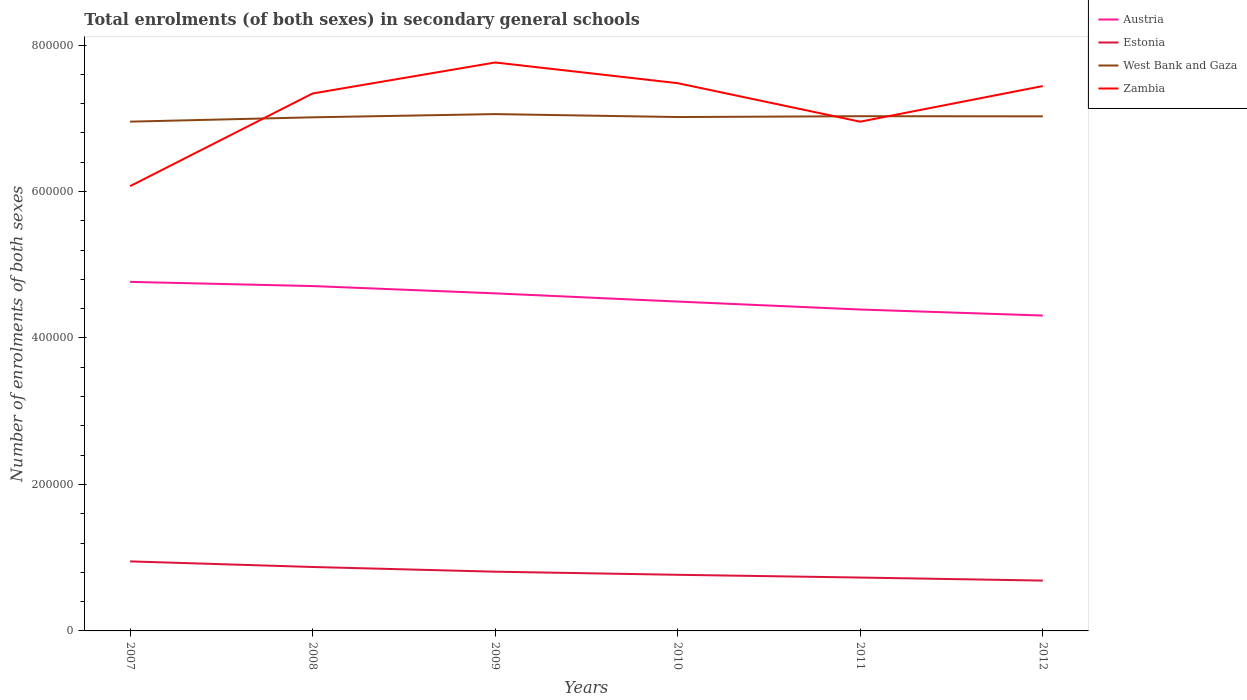How many different coloured lines are there?
Your answer should be very brief. 4. Across all years, what is the maximum number of enrolments in secondary schools in Estonia?
Your answer should be compact. 6.87e+04. What is the total number of enrolments in secondary schools in West Bank and Gaza in the graph?
Ensure brevity in your answer.  4036. What is the difference between the highest and the second highest number of enrolments in secondary schools in Austria?
Keep it short and to the point. 4.60e+04. How many lines are there?
Provide a succinct answer. 4. What is the difference between two consecutive major ticks on the Y-axis?
Ensure brevity in your answer.  2.00e+05. Are the values on the major ticks of Y-axis written in scientific E-notation?
Provide a short and direct response. No. Does the graph contain grids?
Ensure brevity in your answer.  No. How many legend labels are there?
Your answer should be very brief. 4. How are the legend labels stacked?
Provide a short and direct response. Vertical. What is the title of the graph?
Provide a succinct answer. Total enrolments (of both sexes) in secondary general schools. What is the label or title of the X-axis?
Your answer should be very brief. Years. What is the label or title of the Y-axis?
Offer a terse response. Number of enrolments of both sexes. What is the Number of enrolments of both sexes of Austria in 2007?
Your answer should be compact. 4.77e+05. What is the Number of enrolments of both sexes of Estonia in 2007?
Ensure brevity in your answer.  9.49e+04. What is the Number of enrolments of both sexes of West Bank and Gaza in 2007?
Offer a very short reply. 6.95e+05. What is the Number of enrolments of both sexes of Zambia in 2007?
Offer a very short reply. 6.07e+05. What is the Number of enrolments of both sexes in Austria in 2008?
Your response must be concise. 4.71e+05. What is the Number of enrolments of both sexes of Estonia in 2008?
Provide a short and direct response. 8.73e+04. What is the Number of enrolments of both sexes in West Bank and Gaza in 2008?
Offer a very short reply. 7.01e+05. What is the Number of enrolments of both sexes in Zambia in 2008?
Keep it short and to the point. 7.34e+05. What is the Number of enrolments of both sexes of Austria in 2009?
Give a very brief answer. 4.61e+05. What is the Number of enrolments of both sexes in Estonia in 2009?
Ensure brevity in your answer.  8.09e+04. What is the Number of enrolments of both sexes of West Bank and Gaza in 2009?
Your answer should be compact. 7.06e+05. What is the Number of enrolments of both sexes of Zambia in 2009?
Your response must be concise. 7.76e+05. What is the Number of enrolments of both sexes of Austria in 2010?
Your answer should be very brief. 4.50e+05. What is the Number of enrolments of both sexes in Estonia in 2010?
Your answer should be very brief. 7.66e+04. What is the Number of enrolments of both sexes of West Bank and Gaza in 2010?
Give a very brief answer. 7.02e+05. What is the Number of enrolments of both sexes in Zambia in 2010?
Your answer should be compact. 7.48e+05. What is the Number of enrolments of both sexes in Austria in 2011?
Offer a terse response. 4.39e+05. What is the Number of enrolments of both sexes in Estonia in 2011?
Your answer should be compact. 7.29e+04. What is the Number of enrolments of both sexes of West Bank and Gaza in 2011?
Your answer should be compact. 7.03e+05. What is the Number of enrolments of both sexes of Zambia in 2011?
Offer a very short reply. 6.95e+05. What is the Number of enrolments of both sexes of Austria in 2012?
Provide a short and direct response. 4.31e+05. What is the Number of enrolments of both sexes in Estonia in 2012?
Provide a succinct answer. 6.87e+04. What is the Number of enrolments of both sexes in West Bank and Gaza in 2012?
Provide a succinct answer. 7.03e+05. What is the Number of enrolments of both sexes in Zambia in 2012?
Your answer should be very brief. 7.44e+05. Across all years, what is the maximum Number of enrolments of both sexes of Austria?
Make the answer very short. 4.77e+05. Across all years, what is the maximum Number of enrolments of both sexes in Estonia?
Your response must be concise. 9.49e+04. Across all years, what is the maximum Number of enrolments of both sexes in West Bank and Gaza?
Your response must be concise. 7.06e+05. Across all years, what is the maximum Number of enrolments of both sexes of Zambia?
Make the answer very short. 7.76e+05. Across all years, what is the minimum Number of enrolments of both sexes of Austria?
Offer a terse response. 4.31e+05. Across all years, what is the minimum Number of enrolments of both sexes in Estonia?
Ensure brevity in your answer.  6.87e+04. Across all years, what is the minimum Number of enrolments of both sexes in West Bank and Gaza?
Your answer should be compact. 6.95e+05. Across all years, what is the minimum Number of enrolments of both sexes in Zambia?
Your answer should be very brief. 6.07e+05. What is the total Number of enrolments of both sexes of Austria in the graph?
Keep it short and to the point. 2.73e+06. What is the total Number of enrolments of both sexes in Estonia in the graph?
Provide a short and direct response. 4.81e+05. What is the total Number of enrolments of both sexes of West Bank and Gaza in the graph?
Offer a terse response. 4.21e+06. What is the total Number of enrolments of both sexes in Zambia in the graph?
Your response must be concise. 4.30e+06. What is the difference between the Number of enrolments of both sexes in Austria in 2007 and that in 2008?
Give a very brief answer. 5735. What is the difference between the Number of enrolments of both sexes of Estonia in 2007 and that in 2008?
Your response must be concise. 7637. What is the difference between the Number of enrolments of both sexes in West Bank and Gaza in 2007 and that in 2008?
Provide a short and direct response. -5912. What is the difference between the Number of enrolments of both sexes in Zambia in 2007 and that in 2008?
Provide a succinct answer. -1.27e+05. What is the difference between the Number of enrolments of both sexes in Austria in 2007 and that in 2009?
Ensure brevity in your answer.  1.57e+04. What is the difference between the Number of enrolments of both sexes of Estonia in 2007 and that in 2009?
Keep it short and to the point. 1.41e+04. What is the difference between the Number of enrolments of both sexes in West Bank and Gaza in 2007 and that in 2009?
Keep it short and to the point. -1.03e+04. What is the difference between the Number of enrolments of both sexes of Zambia in 2007 and that in 2009?
Provide a succinct answer. -1.69e+05. What is the difference between the Number of enrolments of both sexes of Austria in 2007 and that in 2010?
Your answer should be compact. 2.69e+04. What is the difference between the Number of enrolments of both sexes in Estonia in 2007 and that in 2010?
Your answer should be compact. 1.83e+04. What is the difference between the Number of enrolments of both sexes of West Bank and Gaza in 2007 and that in 2010?
Your response must be concise. -6284. What is the difference between the Number of enrolments of both sexes of Zambia in 2007 and that in 2010?
Make the answer very short. -1.41e+05. What is the difference between the Number of enrolments of both sexes of Austria in 2007 and that in 2011?
Your response must be concise. 3.77e+04. What is the difference between the Number of enrolments of both sexes of Estonia in 2007 and that in 2011?
Offer a terse response. 2.20e+04. What is the difference between the Number of enrolments of both sexes in West Bank and Gaza in 2007 and that in 2011?
Ensure brevity in your answer.  -7430. What is the difference between the Number of enrolments of both sexes of Zambia in 2007 and that in 2011?
Your answer should be very brief. -8.81e+04. What is the difference between the Number of enrolments of both sexes of Austria in 2007 and that in 2012?
Make the answer very short. 4.60e+04. What is the difference between the Number of enrolments of both sexes in Estonia in 2007 and that in 2012?
Ensure brevity in your answer.  2.62e+04. What is the difference between the Number of enrolments of both sexes of West Bank and Gaza in 2007 and that in 2012?
Offer a terse response. -7242. What is the difference between the Number of enrolments of both sexes in Zambia in 2007 and that in 2012?
Provide a succinct answer. -1.37e+05. What is the difference between the Number of enrolments of both sexes of Austria in 2008 and that in 2009?
Provide a short and direct response. 9955. What is the difference between the Number of enrolments of both sexes in Estonia in 2008 and that in 2009?
Your answer should be very brief. 6423. What is the difference between the Number of enrolments of both sexes of West Bank and Gaza in 2008 and that in 2009?
Give a very brief answer. -4408. What is the difference between the Number of enrolments of both sexes in Zambia in 2008 and that in 2009?
Your answer should be very brief. -4.23e+04. What is the difference between the Number of enrolments of both sexes in Austria in 2008 and that in 2010?
Provide a succinct answer. 2.12e+04. What is the difference between the Number of enrolments of both sexes of Estonia in 2008 and that in 2010?
Offer a very short reply. 1.07e+04. What is the difference between the Number of enrolments of both sexes of West Bank and Gaza in 2008 and that in 2010?
Provide a short and direct response. -372. What is the difference between the Number of enrolments of both sexes of Zambia in 2008 and that in 2010?
Ensure brevity in your answer.  -1.41e+04. What is the difference between the Number of enrolments of both sexes in Austria in 2008 and that in 2011?
Offer a terse response. 3.20e+04. What is the difference between the Number of enrolments of both sexes in Estonia in 2008 and that in 2011?
Offer a very short reply. 1.44e+04. What is the difference between the Number of enrolments of both sexes in West Bank and Gaza in 2008 and that in 2011?
Give a very brief answer. -1518. What is the difference between the Number of enrolments of both sexes in Zambia in 2008 and that in 2011?
Offer a terse response. 3.85e+04. What is the difference between the Number of enrolments of both sexes in Austria in 2008 and that in 2012?
Your answer should be compact. 4.02e+04. What is the difference between the Number of enrolments of both sexes in Estonia in 2008 and that in 2012?
Offer a very short reply. 1.86e+04. What is the difference between the Number of enrolments of both sexes of West Bank and Gaza in 2008 and that in 2012?
Give a very brief answer. -1330. What is the difference between the Number of enrolments of both sexes in Zambia in 2008 and that in 2012?
Ensure brevity in your answer.  -1.01e+04. What is the difference between the Number of enrolments of both sexes of Austria in 2009 and that in 2010?
Keep it short and to the point. 1.12e+04. What is the difference between the Number of enrolments of both sexes in Estonia in 2009 and that in 2010?
Provide a short and direct response. 4230. What is the difference between the Number of enrolments of both sexes in West Bank and Gaza in 2009 and that in 2010?
Keep it short and to the point. 4036. What is the difference between the Number of enrolments of both sexes of Zambia in 2009 and that in 2010?
Give a very brief answer. 2.83e+04. What is the difference between the Number of enrolments of both sexes of Austria in 2009 and that in 2011?
Your answer should be very brief. 2.21e+04. What is the difference between the Number of enrolments of both sexes of Estonia in 2009 and that in 2011?
Provide a short and direct response. 7990. What is the difference between the Number of enrolments of both sexes in West Bank and Gaza in 2009 and that in 2011?
Make the answer very short. 2890. What is the difference between the Number of enrolments of both sexes in Zambia in 2009 and that in 2011?
Make the answer very short. 8.08e+04. What is the difference between the Number of enrolments of both sexes of Austria in 2009 and that in 2012?
Your response must be concise. 3.03e+04. What is the difference between the Number of enrolments of both sexes of Estonia in 2009 and that in 2012?
Make the answer very short. 1.21e+04. What is the difference between the Number of enrolments of both sexes in West Bank and Gaza in 2009 and that in 2012?
Offer a terse response. 3078. What is the difference between the Number of enrolments of both sexes in Zambia in 2009 and that in 2012?
Ensure brevity in your answer.  3.22e+04. What is the difference between the Number of enrolments of both sexes in Austria in 2010 and that in 2011?
Provide a short and direct response. 1.08e+04. What is the difference between the Number of enrolments of both sexes in Estonia in 2010 and that in 2011?
Make the answer very short. 3760. What is the difference between the Number of enrolments of both sexes in West Bank and Gaza in 2010 and that in 2011?
Make the answer very short. -1146. What is the difference between the Number of enrolments of both sexes of Zambia in 2010 and that in 2011?
Give a very brief answer. 5.26e+04. What is the difference between the Number of enrolments of both sexes of Austria in 2010 and that in 2012?
Ensure brevity in your answer.  1.91e+04. What is the difference between the Number of enrolments of both sexes of Estonia in 2010 and that in 2012?
Keep it short and to the point. 7911. What is the difference between the Number of enrolments of both sexes in West Bank and Gaza in 2010 and that in 2012?
Your response must be concise. -958. What is the difference between the Number of enrolments of both sexes of Zambia in 2010 and that in 2012?
Your answer should be very brief. 3940. What is the difference between the Number of enrolments of both sexes in Austria in 2011 and that in 2012?
Your answer should be compact. 8222.16. What is the difference between the Number of enrolments of both sexes of Estonia in 2011 and that in 2012?
Offer a very short reply. 4151. What is the difference between the Number of enrolments of both sexes in West Bank and Gaza in 2011 and that in 2012?
Ensure brevity in your answer.  188. What is the difference between the Number of enrolments of both sexes in Zambia in 2011 and that in 2012?
Keep it short and to the point. -4.86e+04. What is the difference between the Number of enrolments of both sexes in Austria in 2007 and the Number of enrolments of both sexes in Estonia in 2008?
Provide a short and direct response. 3.89e+05. What is the difference between the Number of enrolments of both sexes of Austria in 2007 and the Number of enrolments of both sexes of West Bank and Gaza in 2008?
Provide a succinct answer. -2.25e+05. What is the difference between the Number of enrolments of both sexes in Austria in 2007 and the Number of enrolments of both sexes in Zambia in 2008?
Keep it short and to the point. -2.57e+05. What is the difference between the Number of enrolments of both sexes in Estonia in 2007 and the Number of enrolments of both sexes in West Bank and Gaza in 2008?
Make the answer very short. -6.06e+05. What is the difference between the Number of enrolments of both sexes of Estonia in 2007 and the Number of enrolments of both sexes of Zambia in 2008?
Provide a short and direct response. -6.39e+05. What is the difference between the Number of enrolments of both sexes in West Bank and Gaza in 2007 and the Number of enrolments of both sexes in Zambia in 2008?
Give a very brief answer. -3.85e+04. What is the difference between the Number of enrolments of both sexes of Austria in 2007 and the Number of enrolments of both sexes of Estonia in 2009?
Provide a succinct answer. 3.96e+05. What is the difference between the Number of enrolments of both sexes of Austria in 2007 and the Number of enrolments of both sexes of West Bank and Gaza in 2009?
Your answer should be compact. -2.29e+05. What is the difference between the Number of enrolments of both sexes of Austria in 2007 and the Number of enrolments of both sexes of Zambia in 2009?
Make the answer very short. -3.00e+05. What is the difference between the Number of enrolments of both sexes of Estonia in 2007 and the Number of enrolments of both sexes of West Bank and Gaza in 2009?
Offer a very short reply. -6.11e+05. What is the difference between the Number of enrolments of both sexes in Estonia in 2007 and the Number of enrolments of both sexes in Zambia in 2009?
Provide a short and direct response. -6.81e+05. What is the difference between the Number of enrolments of both sexes in West Bank and Gaza in 2007 and the Number of enrolments of both sexes in Zambia in 2009?
Give a very brief answer. -8.08e+04. What is the difference between the Number of enrolments of both sexes of Austria in 2007 and the Number of enrolments of both sexes of Estonia in 2010?
Keep it short and to the point. 4.00e+05. What is the difference between the Number of enrolments of both sexes in Austria in 2007 and the Number of enrolments of both sexes in West Bank and Gaza in 2010?
Provide a short and direct response. -2.25e+05. What is the difference between the Number of enrolments of both sexes of Austria in 2007 and the Number of enrolments of both sexes of Zambia in 2010?
Ensure brevity in your answer.  -2.71e+05. What is the difference between the Number of enrolments of both sexes in Estonia in 2007 and the Number of enrolments of both sexes in West Bank and Gaza in 2010?
Offer a terse response. -6.07e+05. What is the difference between the Number of enrolments of both sexes of Estonia in 2007 and the Number of enrolments of both sexes of Zambia in 2010?
Provide a short and direct response. -6.53e+05. What is the difference between the Number of enrolments of both sexes in West Bank and Gaza in 2007 and the Number of enrolments of both sexes in Zambia in 2010?
Provide a short and direct response. -5.25e+04. What is the difference between the Number of enrolments of both sexes of Austria in 2007 and the Number of enrolments of both sexes of Estonia in 2011?
Offer a very short reply. 4.04e+05. What is the difference between the Number of enrolments of both sexes in Austria in 2007 and the Number of enrolments of both sexes in West Bank and Gaza in 2011?
Keep it short and to the point. -2.26e+05. What is the difference between the Number of enrolments of both sexes of Austria in 2007 and the Number of enrolments of both sexes of Zambia in 2011?
Ensure brevity in your answer.  -2.19e+05. What is the difference between the Number of enrolments of both sexes of Estonia in 2007 and the Number of enrolments of both sexes of West Bank and Gaza in 2011?
Ensure brevity in your answer.  -6.08e+05. What is the difference between the Number of enrolments of both sexes of Estonia in 2007 and the Number of enrolments of both sexes of Zambia in 2011?
Ensure brevity in your answer.  -6.00e+05. What is the difference between the Number of enrolments of both sexes in Austria in 2007 and the Number of enrolments of both sexes in Estonia in 2012?
Make the answer very short. 4.08e+05. What is the difference between the Number of enrolments of both sexes in Austria in 2007 and the Number of enrolments of both sexes in West Bank and Gaza in 2012?
Provide a succinct answer. -2.26e+05. What is the difference between the Number of enrolments of both sexes in Austria in 2007 and the Number of enrolments of both sexes in Zambia in 2012?
Your answer should be very brief. -2.67e+05. What is the difference between the Number of enrolments of both sexes in Estonia in 2007 and the Number of enrolments of both sexes in West Bank and Gaza in 2012?
Your answer should be very brief. -6.08e+05. What is the difference between the Number of enrolments of both sexes in Estonia in 2007 and the Number of enrolments of both sexes in Zambia in 2012?
Keep it short and to the point. -6.49e+05. What is the difference between the Number of enrolments of both sexes of West Bank and Gaza in 2007 and the Number of enrolments of both sexes of Zambia in 2012?
Offer a terse response. -4.86e+04. What is the difference between the Number of enrolments of both sexes in Austria in 2008 and the Number of enrolments of both sexes in Estonia in 2009?
Give a very brief answer. 3.90e+05. What is the difference between the Number of enrolments of both sexes of Austria in 2008 and the Number of enrolments of both sexes of West Bank and Gaza in 2009?
Your answer should be very brief. -2.35e+05. What is the difference between the Number of enrolments of both sexes in Austria in 2008 and the Number of enrolments of both sexes in Zambia in 2009?
Make the answer very short. -3.05e+05. What is the difference between the Number of enrolments of both sexes in Estonia in 2008 and the Number of enrolments of both sexes in West Bank and Gaza in 2009?
Offer a terse response. -6.18e+05. What is the difference between the Number of enrolments of both sexes of Estonia in 2008 and the Number of enrolments of both sexes of Zambia in 2009?
Your response must be concise. -6.89e+05. What is the difference between the Number of enrolments of both sexes of West Bank and Gaza in 2008 and the Number of enrolments of both sexes of Zambia in 2009?
Your response must be concise. -7.49e+04. What is the difference between the Number of enrolments of both sexes in Austria in 2008 and the Number of enrolments of both sexes in Estonia in 2010?
Give a very brief answer. 3.94e+05. What is the difference between the Number of enrolments of both sexes of Austria in 2008 and the Number of enrolments of both sexes of West Bank and Gaza in 2010?
Keep it short and to the point. -2.31e+05. What is the difference between the Number of enrolments of both sexes of Austria in 2008 and the Number of enrolments of both sexes of Zambia in 2010?
Your answer should be compact. -2.77e+05. What is the difference between the Number of enrolments of both sexes of Estonia in 2008 and the Number of enrolments of both sexes of West Bank and Gaza in 2010?
Your answer should be compact. -6.14e+05. What is the difference between the Number of enrolments of both sexes of Estonia in 2008 and the Number of enrolments of both sexes of Zambia in 2010?
Provide a succinct answer. -6.61e+05. What is the difference between the Number of enrolments of both sexes in West Bank and Gaza in 2008 and the Number of enrolments of both sexes in Zambia in 2010?
Provide a short and direct response. -4.66e+04. What is the difference between the Number of enrolments of both sexes in Austria in 2008 and the Number of enrolments of both sexes in Estonia in 2011?
Offer a very short reply. 3.98e+05. What is the difference between the Number of enrolments of both sexes of Austria in 2008 and the Number of enrolments of both sexes of West Bank and Gaza in 2011?
Give a very brief answer. -2.32e+05. What is the difference between the Number of enrolments of both sexes of Austria in 2008 and the Number of enrolments of both sexes of Zambia in 2011?
Provide a short and direct response. -2.24e+05. What is the difference between the Number of enrolments of both sexes of Estonia in 2008 and the Number of enrolments of both sexes of West Bank and Gaza in 2011?
Offer a very short reply. -6.16e+05. What is the difference between the Number of enrolments of both sexes in Estonia in 2008 and the Number of enrolments of both sexes in Zambia in 2011?
Your response must be concise. -6.08e+05. What is the difference between the Number of enrolments of both sexes in West Bank and Gaza in 2008 and the Number of enrolments of both sexes in Zambia in 2011?
Offer a terse response. 5955. What is the difference between the Number of enrolments of both sexes of Austria in 2008 and the Number of enrolments of both sexes of Estonia in 2012?
Your answer should be very brief. 4.02e+05. What is the difference between the Number of enrolments of both sexes of Austria in 2008 and the Number of enrolments of both sexes of West Bank and Gaza in 2012?
Ensure brevity in your answer.  -2.32e+05. What is the difference between the Number of enrolments of both sexes of Austria in 2008 and the Number of enrolments of both sexes of Zambia in 2012?
Provide a short and direct response. -2.73e+05. What is the difference between the Number of enrolments of both sexes in Estonia in 2008 and the Number of enrolments of both sexes in West Bank and Gaza in 2012?
Provide a succinct answer. -6.15e+05. What is the difference between the Number of enrolments of both sexes in Estonia in 2008 and the Number of enrolments of both sexes in Zambia in 2012?
Your answer should be very brief. -6.57e+05. What is the difference between the Number of enrolments of both sexes of West Bank and Gaza in 2008 and the Number of enrolments of both sexes of Zambia in 2012?
Your answer should be very brief. -4.27e+04. What is the difference between the Number of enrolments of both sexes of Austria in 2009 and the Number of enrolments of both sexes of Estonia in 2010?
Your answer should be very brief. 3.84e+05. What is the difference between the Number of enrolments of both sexes in Austria in 2009 and the Number of enrolments of both sexes in West Bank and Gaza in 2010?
Ensure brevity in your answer.  -2.41e+05. What is the difference between the Number of enrolments of both sexes of Austria in 2009 and the Number of enrolments of both sexes of Zambia in 2010?
Ensure brevity in your answer.  -2.87e+05. What is the difference between the Number of enrolments of both sexes in Estonia in 2009 and the Number of enrolments of both sexes in West Bank and Gaza in 2010?
Your answer should be very brief. -6.21e+05. What is the difference between the Number of enrolments of both sexes in Estonia in 2009 and the Number of enrolments of both sexes in Zambia in 2010?
Your answer should be very brief. -6.67e+05. What is the difference between the Number of enrolments of both sexes in West Bank and Gaza in 2009 and the Number of enrolments of both sexes in Zambia in 2010?
Your response must be concise. -4.22e+04. What is the difference between the Number of enrolments of both sexes in Austria in 2009 and the Number of enrolments of both sexes in Estonia in 2011?
Ensure brevity in your answer.  3.88e+05. What is the difference between the Number of enrolments of both sexes in Austria in 2009 and the Number of enrolments of both sexes in West Bank and Gaza in 2011?
Your answer should be compact. -2.42e+05. What is the difference between the Number of enrolments of both sexes in Austria in 2009 and the Number of enrolments of both sexes in Zambia in 2011?
Your response must be concise. -2.34e+05. What is the difference between the Number of enrolments of both sexes of Estonia in 2009 and the Number of enrolments of both sexes of West Bank and Gaza in 2011?
Offer a very short reply. -6.22e+05. What is the difference between the Number of enrolments of both sexes of Estonia in 2009 and the Number of enrolments of both sexes of Zambia in 2011?
Provide a succinct answer. -6.14e+05. What is the difference between the Number of enrolments of both sexes of West Bank and Gaza in 2009 and the Number of enrolments of both sexes of Zambia in 2011?
Your answer should be compact. 1.04e+04. What is the difference between the Number of enrolments of both sexes of Austria in 2009 and the Number of enrolments of both sexes of Estonia in 2012?
Provide a short and direct response. 3.92e+05. What is the difference between the Number of enrolments of both sexes in Austria in 2009 and the Number of enrolments of both sexes in West Bank and Gaza in 2012?
Give a very brief answer. -2.42e+05. What is the difference between the Number of enrolments of both sexes in Austria in 2009 and the Number of enrolments of both sexes in Zambia in 2012?
Give a very brief answer. -2.83e+05. What is the difference between the Number of enrolments of both sexes in Estonia in 2009 and the Number of enrolments of both sexes in West Bank and Gaza in 2012?
Ensure brevity in your answer.  -6.22e+05. What is the difference between the Number of enrolments of both sexes of Estonia in 2009 and the Number of enrolments of both sexes of Zambia in 2012?
Provide a succinct answer. -6.63e+05. What is the difference between the Number of enrolments of both sexes of West Bank and Gaza in 2009 and the Number of enrolments of both sexes of Zambia in 2012?
Make the answer very short. -3.83e+04. What is the difference between the Number of enrolments of both sexes in Austria in 2010 and the Number of enrolments of both sexes in Estonia in 2011?
Offer a terse response. 3.77e+05. What is the difference between the Number of enrolments of both sexes of Austria in 2010 and the Number of enrolments of both sexes of West Bank and Gaza in 2011?
Your answer should be compact. -2.53e+05. What is the difference between the Number of enrolments of both sexes of Austria in 2010 and the Number of enrolments of both sexes of Zambia in 2011?
Make the answer very short. -2.46e+05. What is the difference between the Number of enrolments of both sexes of Estonia in 2010 and the Number of enrolments of both sexes of West Bank and Gaza in 2011?
Provide a succinct answer. -6.26e+05. What is the difference between the Number of enrolments of both sexes in Estonia in 2010 and the Number of enrolments of both sexes in Zambia in 2011?
Your answer should be compact. -6.19e+05. What is the difference between the Number of enrolments of both sexes of West Bank and Gaza in 2010 and the Number of enrolments of both sexes of Zambia in 2011?
Provide a short and direct response. 6327. What is the difference between the Number of enrolments of both sexes in Austria in 2010 and the Number of enrolments of both sexes in Estonia in 2012?
Make the answer very short. 3.81e+05. What is the difference between the Number of enrolments of both sexes in Austria in 2010 and the Number of enrolments of both sexes in West Bank and Gaza in 2012?
Provide a short and direct response. -2.53e+05. What is the difference between the Number of enrolments of both sexes of Austria in 2010 and the Number of enrolments of both sexes of Zambia in 2012?
Make the answer very short. -2.94e+05. What is the difference between the Number of enrolments of both sexes of Estonia in 2010 and the Number of enrolments of both sexes of West Bank and Gaza in 2012?
Provide a succinct answer. -6.26e+05. What is the difference between the Number of enrolments of both sexes in Estonia in 2010 and the Number of enrolments of both sexes in Zambia in 2012?
Keep it short and to the point. -6.67e+05. What is the difference between the Number of enrolments of both sexes in West Bank and Gaza in 2010 and the Number of enrolments of both sexes in Zambia in 2012?
Your response must be concise. -4.23e+04. What is the difference between the Number of enrolments of both sexes in Austria in 2011 and the Number of enrolments of both sexes in Estonia in 2012?
Your answer should be very brief. 3.70e+05. What is the difference between the Number of enrolments of both sexes of Austria in 2011 and the Number of enrolments of both sexes of West Bank and Gaza in 2012?
Make the answer very short. -2.64e+05. What is the difference between the Number of enrolments of both sexes of Austria in 2011 and the Number of enrolments of both sexes of Zambia in 2012?
Give a very brief answer. -3.05e+05. What is the difference between the Number of enrolments of both sexes in Estonia in 2011 and the Number of enrolments of both sexes in West Bank and Gaza in 2012?
Offer a very short reply. -6.30e+05. What is the difference between the Number of enrolments of both sexes of Estonia in 2011 and the Number of enrolments of both sexes of Zambia in 2012?
Provide a succinct answer. -6.71e+05. What is the difference between the Number of enrolments of both sexes of West Bank and Gaza in 2011 and the Number of enrolments of both sexes of Zambia in 2012?
Give a very brief answer. -4.12e+04. What is the average Number of enrolments of both sexes in Austria per year?
Your answer should be very brief. 4.55e+05. What is the average Number of enrolments of both sexes of Estonia per year?
Give a very brief answer. 8.02e+04. What is the average Number of enrolments of both sexes in West Bank and Gaza per year?
Keep it short and to the point. 7.02e+05. What is the average Number of enrolments of both sexes of Zambia per year?
Provide a short and direct response. 7.17e+05. In the year 2007, what is the difference between the Number of enrolments of both sexes of Austria and Number of enrolments of both sexes of Estonia?
Your answer should be compact. 3.82e+05. In the year 2007, what is the difference between the Number of enrolments of both sexes of Austria and Number of enrolments of both sexes of West Bank and Gaza?
Keep it short and to the point. -2.19e+05. In the year 2007, what is the difference between the Number of enrolments of both sexes of Austria and Number of enrolments of both sexes of Zambia?
Your response must be concise. -1.31e+05. In the year 2007, what is the difference between the Number of enrolments of both sexes of Estonia and Number of enrolments of both sexes of West Bank and Gaza?
Your answer should be compact. -6.00e+05. In the year 2007, what is the difference between the Number of enrolments of both sexes of Estonia and Number of enrolments of both sexes of Zambia?
Make the answer very short. -5.12e+05. In the year 2007, what is the difference between the Number of enrolments of both sexes in West Bank and Gaza and Number of enrolments of both sexes in Zambia?
Provide a short and direct response. 8.81e+04. In the year 2008, what is the difference between the Number of enrolments of both sexes of Austria and Number of enrolments of both sexes of Estonia?
Make the answer very short. 3.84e+05. In the year 2008, what is the difference between the Number of enrolments of both sexes in Austria and Number of enrolments of both sexes in West Bank and Gaza?
Provide a short and direct response. -2.30e+05. In the year 2008, what is the difference between the Number of enrolments of both sexes of Austria and Number of enrolments of both sexes of Zambia?
Provide a succinct answer. -2.63e+05. In the year 2008, what is the difference between the Number of enrolments of both sexes of Estonia and Number of enrolments of both sexes of West Bank and Gaza?
Provide a succinct answer. -6.14e+05. In the year 2008, what is the difference between the Number of enrolments of both sexes in Estonia and Number of enrolments of both sexes in Zambia?
Ensure brevity in your answer.  -6.47e+05. In the year 2008, what is the difference between the Number of enrolments of both sexes in West Bank and Gaza and Number of enrolments of both sexes in Zambia?
Your answer should be very brief. -3.26e+04. In the year 2009, what is the difference between the Number of enrolments of both sexes in Austria and Number of enrolments of both sexes in Estonia?
Your response must be concise. 3.80e+05. In the year 2009, what is the difference between the Number of enrolments of both sexes in Austria and Number of enrolments of both sexes in West Bank and Gaza?
Make the answer very short. -2.45e+05. In the year 2009, what is the difference between the Number of enrolments of both sexes in Austria and Number of enrolments of both sexes in Zambia?
Ensure brevity in your answer.  -3.15e+05. In the year 2009, what is the difference between the Number of enrolments of both sexes of Estonia and Number of enrolments of both sexes of West Bank and Gaza?
Offer a very short reply. -6.25e+05. In the year 2009, what is the difference between the Number of enrolments of both sexes in Estonia and Number of enrolments of both sexes in Zambia?
Make the answer very short. -6.95e+05. In the year 2009, what is the difference between the Number of enrolments of both sexes in West Bank and Gaza and Number of enrolments of both sexes in Zambia?
Your answer should be compact. -7.05e+04. In the year 2010, what is the difference between the Number of enrolments of both sexes in Austria and Number of enrolments of both sexes in Estonia?
Offer a terse response. 3.73e+05. In the year 2010, what is the difference between the Number of enrolments of both sexes in Austria and Number of enrolments of both sexes in West Bank and Gaza?
Provide a short and direct response. -2.52e+05. In the year 2010, what is the difference between the Number of enrolments of both sexes in Austria and Number of enrolments of both sexes in Zambia?
Make the answer very short. -2.98e+05. In the year 2010, what is the difference between the Number of enrolments of both sexes in Estonia and Number of enrolments of both sexes in West Bank and Gaza?
Keep it short and to the point. -6.25e+05. In the year 2010, what is the difference between the Number of enrolments of both sexes in Estonia and Number of enrolments of both sexes in Zambia?
Offer a very short reply. -6.71e+05. In the year 2010, what is the difference between the Number of enrolments of both sexes in West Bank and Gaza and Number of enrolments of both sexes in Zambia?
Your answer should be compact. -4.63e+04. In the year 2011, what is the difference between the Number of enrolments of both sexes in Austria and Number of enrolments of both sexes in Estonia?
Provide a succinct answer. 3.66e+05. In the year 2011, what is the difference between the Number of enrolments of both sexes of Austria and Number of enrolments of both sexes of West Bank and Gaza?
Your response must be concise. -2.64e+05. In the year 2011, what is the difference between the Number of enrolments of both sexes in Austria and Number of enrolments of both sexes in Zambia?
Your answer should be compact. -2.56e+05. In the year 2011, what is the difference between the Number of enrolments of both sexes of Estonia and Number of enrolments of both sexes of West Bank and Gaza?
Give a very brief answer. -6.30e+05. In the year 2011, what is the difference between the Number of enrolments of both sexes in Estonia and Number of enrolments of both sexes in Zambia?
Your answer should be compact. -6.22e+05. In the year 2011, what is the difference between the Number of enrolments of both sexes in West Bank and Gaza and Number of enrolments of both sexes in Zambia?
Offer a very short reply. 7473. In the year 2012, what is the difference between the Number of enrolments of both sexes of Austria and Number of enrolments of both sexes of Estonia?
Give a very brief answer. 3.62e+05. In the year 2012, what is the difference between the Number of enrolments of both sexes in Austria and Number of enrolments of both sexes in West Bank and Gaza?
Offer a terse response. -2.72e+05. In the year 2012, what is the difference between the Number of enrolments of both sexes in Austria and Number of enrolments of both sexes in Zambia?
Provide a succinct answer. -3.13e+05. In the year 2012, what is the difference between the Number of enrolments of both sexes of Estonia and Number of enrolments of both sexes of West Bank and Gaza?
Ensure brevity in your answer.  -6.34e+05. In the year 2012, what is the difference between the Number of enrolments of both sexes in Estonia and Number of enrolments of both sexes in Zambia?
Give a very brief answer. -6.75e+05. In the year 2012, what is the difference between the Number of enrolments of both sexes of West Bank and Gaza and Number of enrolments of both sexes of Zambia?
Provide a succinct answer. -4.14e+04. What is the ratio of the Number of enrolments of both sexes in Austria in 2007 to that in 2008?
Your response must be concise. 1.01. What is the ratio of the Number of enrolments of both sexes of Estonia in 2007 to that in 2008?
Ensure brevity in your answer.  1.09. What is the ratio of the Number of enrolments of both sexes in West Bank and Gaza in 2007 to that in 2008?
Make the answer very short. 0.99. What is the ratio of the Number of enrolments of both sexes in Zambia in 2007 to that in 2008?
Ensure brevity in your answer.  0.83. What is the ratio of the Number of enrolments of both sexes of Austria in 2007 to that in 2009?
Your answer should be very brief. 1.03. What is the ratio of the Number of enrolments of both sexes of Estonia in 2007 to that in 2009?
Provide a succinct answer. 1.17. What is the ratio of the Number of enrolments of both sexes of West Bank and Gaza in 2007 to that in 2009?
Keep it short and to the point. 0.99. What is the ratio of the Number of enrolments of both sexes in Zambia in 2007 to that in 2009?
Your answer should be very brief. 0.78. What is the ratio of the Number of enrolments of both sexes in Austria in 2007 to that in 2010?
Offer a very short reply. 1.06. What is the ratio of the Number of enrolments of both sexes of Estonia in 2007 to that in 2010?
Provide a short and direct response. 1.24. What is the ratio of the Number of enrolments of both sexes in West Bank and Gaza in 2007 to that in 2010?
Offer a terse response. 0.99. What is the ratio of the Number of enrolments of both sexes of Zambia in 2007 to that in 2010?
Keep it short and to the point. 0.81. What is the ratio of the Number of enrolments of both sexes in Austria in 2007 to that in 2011?
Your answer should be compact. 1.09. What is the ratio of the Number of enrolments of both sexes of Estonia in 2007 to that in 2011?
Your response must be concise. 1.3. What is the ratio of the Number of enrolments of both sexes in Zambia in 2007 to that in 2011?
Offer a terse response. 0.87. What is the ratio of the Number of enrolments of both sexes in Austria in 2007 to that in 2012?
Your response must be concise. 1.11. What is the ratio of the Number of enrolments of both sexes of Estonia in 2007 to that in 2012?
Give a very brief answer. 1.38. What is the ratio of the Number of enrolments of both sexes in Zambia in 2007 to that in 2012?
Make the answer very short. 0.82. What is the ratio of the Number of enrolments of both sexes in Austria in 2008 to that in 2009?
Your answer should be compact. 1.02. What is the ratio of the Number of enrolments of both sexes of Estonia in 2008 to that in 2009?
Ensure brevity in your answer.  1.08. What is the ratio of the Number of enrolments of both sexes in Zambia in 2008 to that in 2009?
Provide a short and direct response. 0.95. What is the ratio of the Number of enrolments of both sexes of Austria in 2008 to that in 2010?
Offer a terse response. 1.05. What is the ratio of the Number of enrolments of both sexes in Estonia in 2008 to that in 2010?
Keep it short and to the point. 1.14. What is the ratio of the Number of enrolments of both sexes of West Bank and Gaza in 2008 to that in 2010?
Offer a terse response. 1. What is the ratio of the Number of enrolments of both sexes of Zambia in 2008 to that in 2010?
Provide a succinct answer. 0.98. What is the ratio of the Number of enrolments of both sexes in Austria in 2008 to that in 2011?
Keep it short and to the point. 1.07. What is the ratio of the Number of enrolments of both sexes in Estonia in 2008 to that in 2011?
Your answer should be very brief. 1.2. What is the ratio of the Number of enrolments of both sexes of West Bank and Gaza in 2008 to that in 2011?
Your answer should be very brief. 1. What is the ratio of the Number of enrolments of both sexes of Zambia in 2008 to that in 2011?
Your response must be concise. 1.06. What is the ratio of the Number of enrolments of both sexes in Austria in 2008 to that in 2012?
Your answer should be compact. 1.09. What is the ratio of the Number of enrolments of both sexes of Estonia in 2008 to that in 2012?
Ensure brevity in your answer.  1.27. What is the ratio of the Number of enrolments of both sexes of West Bank and Gaza in 2008 to that in 2012?
Offer a terse response. 1. What is the ratio of the Number of enrolments of both sexes of Zambia in 2008 to that in 2012?
Offer a very short reply. 0.99. What is the ratio of the Number of enrolments of both sexes of Austria in 2009 to that in 2010?
Keep it short and to the point. 1.02. What is the ratio of the Number of enrolments of both sexes in Estonia in 2009 to that in 2010?
Make the answer very short. 1.06. What is the ratio of the Number of enrolments of both sexes in Zambia in 2009 to that in 2010?
Give a very brief answer. 1.04. What is the ratio of the Number of enrolments of both sexes in Austria in 2009 to that in 2011?
Provide a short and direct response. 1.05. What is the ratio of the Number of enrolments of both sexes in Estonia in 2009 to that in 2011?
Offer a very short reply. 1.11. What is the ratio of the Number of enrolments of both sexes of Zambia in 2009 to that in 2011?
Give a very brief answer. 1.12. What is the ratio of the Number of enrolments of both sexes in Austria in 2009 to that in 2012?
Make the answer very short. 1.07. What is the ratio of the Number of enrolments of both sexes of Estonia in 2009 to that in 2012?
Ensure brevity in your answer.  1.18. What is the ratio of the Number of enrolments of both sexes of West Bank and Gaza in 2009 to that in 2012?
Give a very brief answer. 1. What is the ratio of the Number of enrolments of both sexes in Zambia in 2009 to that in 2012?
Offer a very short reply. 1.04. What is the ratio of the Number of enrolments of both sexes in Austria in 2010 to that in 2011?
Provide a short and direct response. 1.02. What is the ratio of the Number of enrolments of both sexes in Estonia in 2010 to that in 2011?
Your response must be concise. 1.05. What is the ratio of the Number of enrolments of both sexes in West Bank and Gaza in 2010 to that in 2011?
Offer a terse response. 1. What is the ratio of the Number of enrolments of both sexes of Zambia in 2010 to that in 2011?
Offer a terse response. 1.08. What is the ratio of the Number of enrolments of both sexes in Austria in 2010 to that in 2012?
Your answer should be very brief. 1.04. What is the ratio of the Number of enrolments of both sexes in Estonia in 2010 to that in 2012?
Offer a very short reply. 1.12. What is the ratio of the Number of enrolments of both sexes in West Bank and Gaza in 2010 to that in 2012?
Give a very brief answer. 1. What is the ratio of the Number of enrolments of both sexes of Zambia in 2010 to that in 2012?
Your answer should be compact. 1.01. What is the ratio of the Number of enrolments of both sexes of Austria in 2011 to that in 2012?
Provide a short and direct response. 1.02. What is the ratio of the Number of enrolments of both sexes in Estonia in 2011 to that in 2012?
Provide a succinct answer. 1.06. What is the ratio of the Number of enrolments of both sexes of West Bank and Gaza in 2011 to that in 2012?
Provide a short and direct response. 1. What is the ratio of the Number of enrolments of both sexes in Zambia in 2011 to that in 2012?
Ensure brevity in your answer.  0.93. What is the difference between the highest and the second highest Number of enrolments of both sexes of Austria?
Offer a very short reply. 5735. What is the difference between the highest and the second highest Number of enrolments of both sexes in Estonia?
Offer a very short reply. 7637. What is the difference between the highest and the second highest Number of enrolments of both sexes in West Bank and Gaza?
Provide a succinct answer. 2890. What is the difference between the highest and the second highest Number of enrolments of both sexes in Zambia?
Offer a terse response. 2.83e+04. What is the difference between the highest and the lowest Number of enrolments of both sexes of Austria?
Keep it short and to the point. 4.60e+04. What is the difference between the highest and the lowest Number of enrolments of both sexes in Estonia?
Your answer should be very brief. 2.62e+04. What is the difference between the highest and the lowest Number of enrolments of both sexes of West Bank and Gaza?
Keep it short and to the point. 1.03e+04. What is the difference between the highest and the lowest Number of enrolments of both sexes of Zambia?
Make the answer very short. 1.69e+05. 